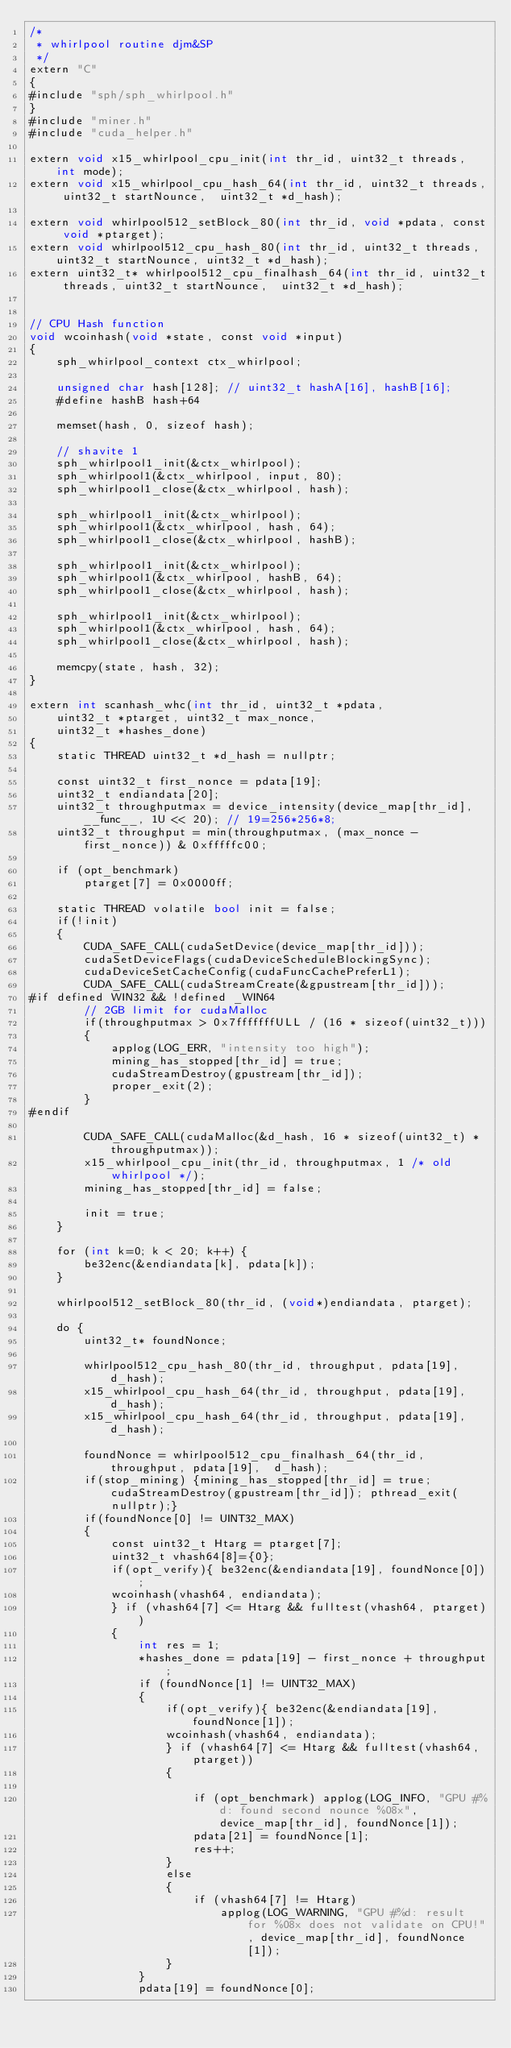<code> <loc_0><loc_0><loc_500><loc_500><_Cuda_>/*
 * whirlpool routine djm&SP
 */
extern "C"
{
#include "sph/sph_whirlpool.h"
}
#include "miner.h"
#include "cuda_helper.h"

extern void x15_whirlpool_cpu_init(int thr_id, uint32_t threads, int mode);
extern void x15_whirlpool_cpu_hash_64(int thr_id, uint32_t threads, uint32_t startNounce,  uint32_t *d_hash);

extern void whirlpool512_setBlock_80(int thr_id, void *pdata, const void *ptarget);
extern void whirlpool512_cpu_hash_80(int thr_id, uint32_t threads, uint32_t startNounce, uint32_t *d_hash);
extern uint32_t* whirlpool512_cpu_finalhash_64(int thr_id, uint32_t threads, uint32_t startNounce,  uint32_t *d_hash);


// CPU Hash function
void wcoinhash(void *state, const void *input)
{
	sph_whirlpool_context ctx_whirlpool;

	unsigned char hash[128]; // uint32_t hashA[16], hashB[16];
	#define hashB hash+64

	memset(hash, 0, sizeof hash);

	// shavite 1
	sph_whirlpool1_init(&ctx_whirlpool);
	sph_whirlpool1(&ctx_whirlpool, input, 80);
	sph_whirlpool1_close(&ctx_whirlpool, hash);

	sph_whirlpool1_init(&ctx_whirlpool);
	sph_whirlpool1(&ctx_whirlpool, hash, 64);
	sph_whirlpool1_close(&ctx_whirlpool, hashB);

	sph_whirlpool1_init(&ctx_whirlpool);
	sph_whirlpool1(&ctx_whirlpool, hashB, 64);
	sph_whirlpool1_close(&ctx_whirlpool, hash);

	sph_whirlpool1_init(&ctx_whirlpool);
	sph_whirlpool1(&ctx_whirlpool, hash, 64);
	sph_whirlpool1_close(&ctx_whirlpool, hash);

	memcpy(state, hash, 32);
}

extern int scanhash_whc(int thr_id, uint32_t *pdata,
    uint32_t *ptarget, uint32_t max_nonce,
    uint32_t *hashes_done)
{
	static THREAD uint32_t *d_hash = nullptr;

	const uint32_t first_nonce = pdata[19];
	uint32_t endiandata[20];
	uint32_t throughputmax = device_intensity(device_map[thr_id], __func__, 1U << 20); // 19=256*256*8;
	uint32_t throughput = min(throughputmax, (max_nonce - first_nonce)) & 0xfffffc00;

	if (opt_benchmark)
		ptarget[7] = 0x0000ff;

	static THREAD volatile bool init = false;
	if(!init)
	{
		CUDA_SAFE_CALL(cudaSetDevice(device_map[thr_id]));
		cudaSetDeviceFlags(cudaDeviceScheduleBlockingSync);
		cudaDeviceSetCacheConfig(cudaFuncCachePreferL1);
		CUDA_SAFE_CALL(cudaStreamCreate(&gpustream[thr_id]));
#if defined WIN32 && !defined _WIN64
		// 2GB limit for cudaMalloc
		if(throughputmax > 0x7fffffffULL / (16 * sizeof(uint32_t)))
		{
			applog(LOG_ERR, "intensity too high");
			mining_has_stopped[thr_id] = true;
			cudaStreamDestroy(gpustream[thr_id]);
			proper_exit(2);
		}
#endif

		CUDA_SAFE_CALL(cudaMalloc(&d_hash, 16 * sizeof(uint32_t) * throughputmax));
		x15_whirlpool_cpu_init(thr_id, throughputmax, 1 /* old whirlpool */);
		mining_has_stopped[thr_id] = false;

		init = true;
	}

	for (int k=0; k < 20; k++) {
		be32enc(&endiandata[k], pdata[k]);
	}

	whirlpool512_setBlock_80(thr_id, (void*)endiandata, ptarget);

	do {
		uint32_t* foundNonce;

		whirlpool512_cpu_hash_80(thr_id, throughput, pdata[19], d_hash);
		x15_whirlpool_cpu_hash_64(thr_id, throughput, pdata[19], d_hash);
		x15_whirlpool_cpu_hash_64(thr_id, throughput, pdata[19], d_hash);

		foundNonce = whirlpool512_cpu_finalhash_64(thr_id, throughput, pdata[19],  d_hash);
		if(stop_mining) {mining_has_stopped[thr_id] = true; cudaStreamDestroy(gpustream[thr_id]); pthread_exit(nullptr);}
		if(foundNonce[0] != UINT32_MAX)
		{
			const uint32_t Htarg = ptarget[7];
			uint32_t vhash64[8]={0};
			if(opt_verify){ be32enc(&endiandata[19], foundNonce[0]);
			wcoinhash(vhash64, endiandata);
			} if (vhash64[7] <= Htarg && fulltest(vhash64, ptarget))
			{
				int res = 1;
				*hashes_done = pdata[19] - first_nonce + throughput;
				if (foundNonce[1] != UINT32_MAX)
				{
					if(opt_verify){ be32enc(&endiandata[19], foundNonce[1]);
					wcoinhash(vhash64, endiandata);
					} if (vhash64[7] <= Htarg && fulltest(vhash64, ptarget))
					{

						if (opt_benchmark) applog(LOG_INFO, "GPU #%d: found second nounce %08x", device_map[thr_id], foundNonce[1]);
						pdata[21] = foundNonce[1];
						res++;
					}
					else
					{
						if (vhash64[7] != Htarg)
							applog(LOG_WARNING, "GPU #%d: result for %08x does not validate on CPU!", device_map[thr_id], foundNonce[1]);
					}
				}
				pdata[19] = foundNonce[0];</code> 